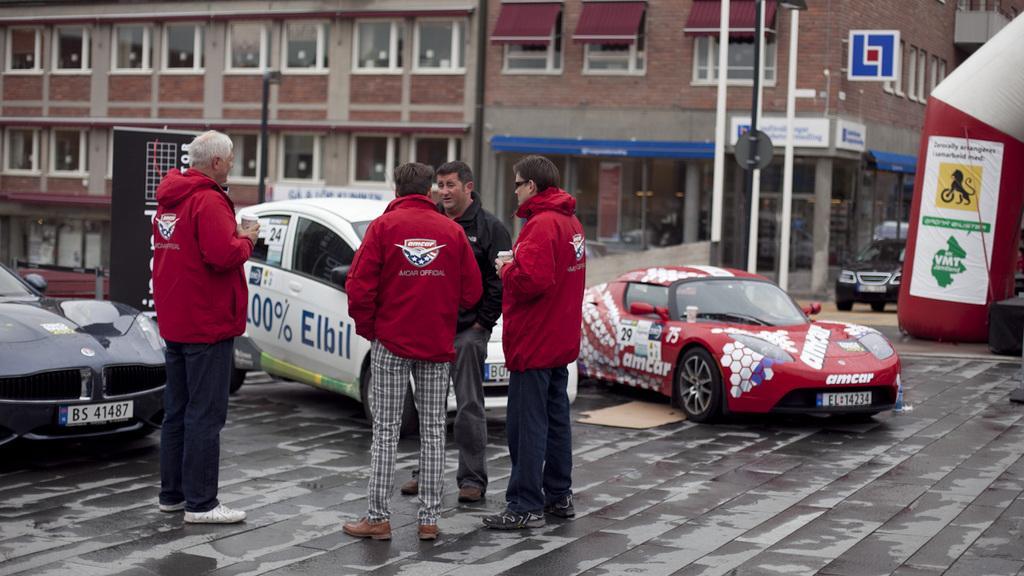Please provide a concise description of this image. In this image I can see four persons standing. In front the person is wearing red and black color dress and I can see few vehicles. In the background I can see few buildings, windows, poles and few objects. 